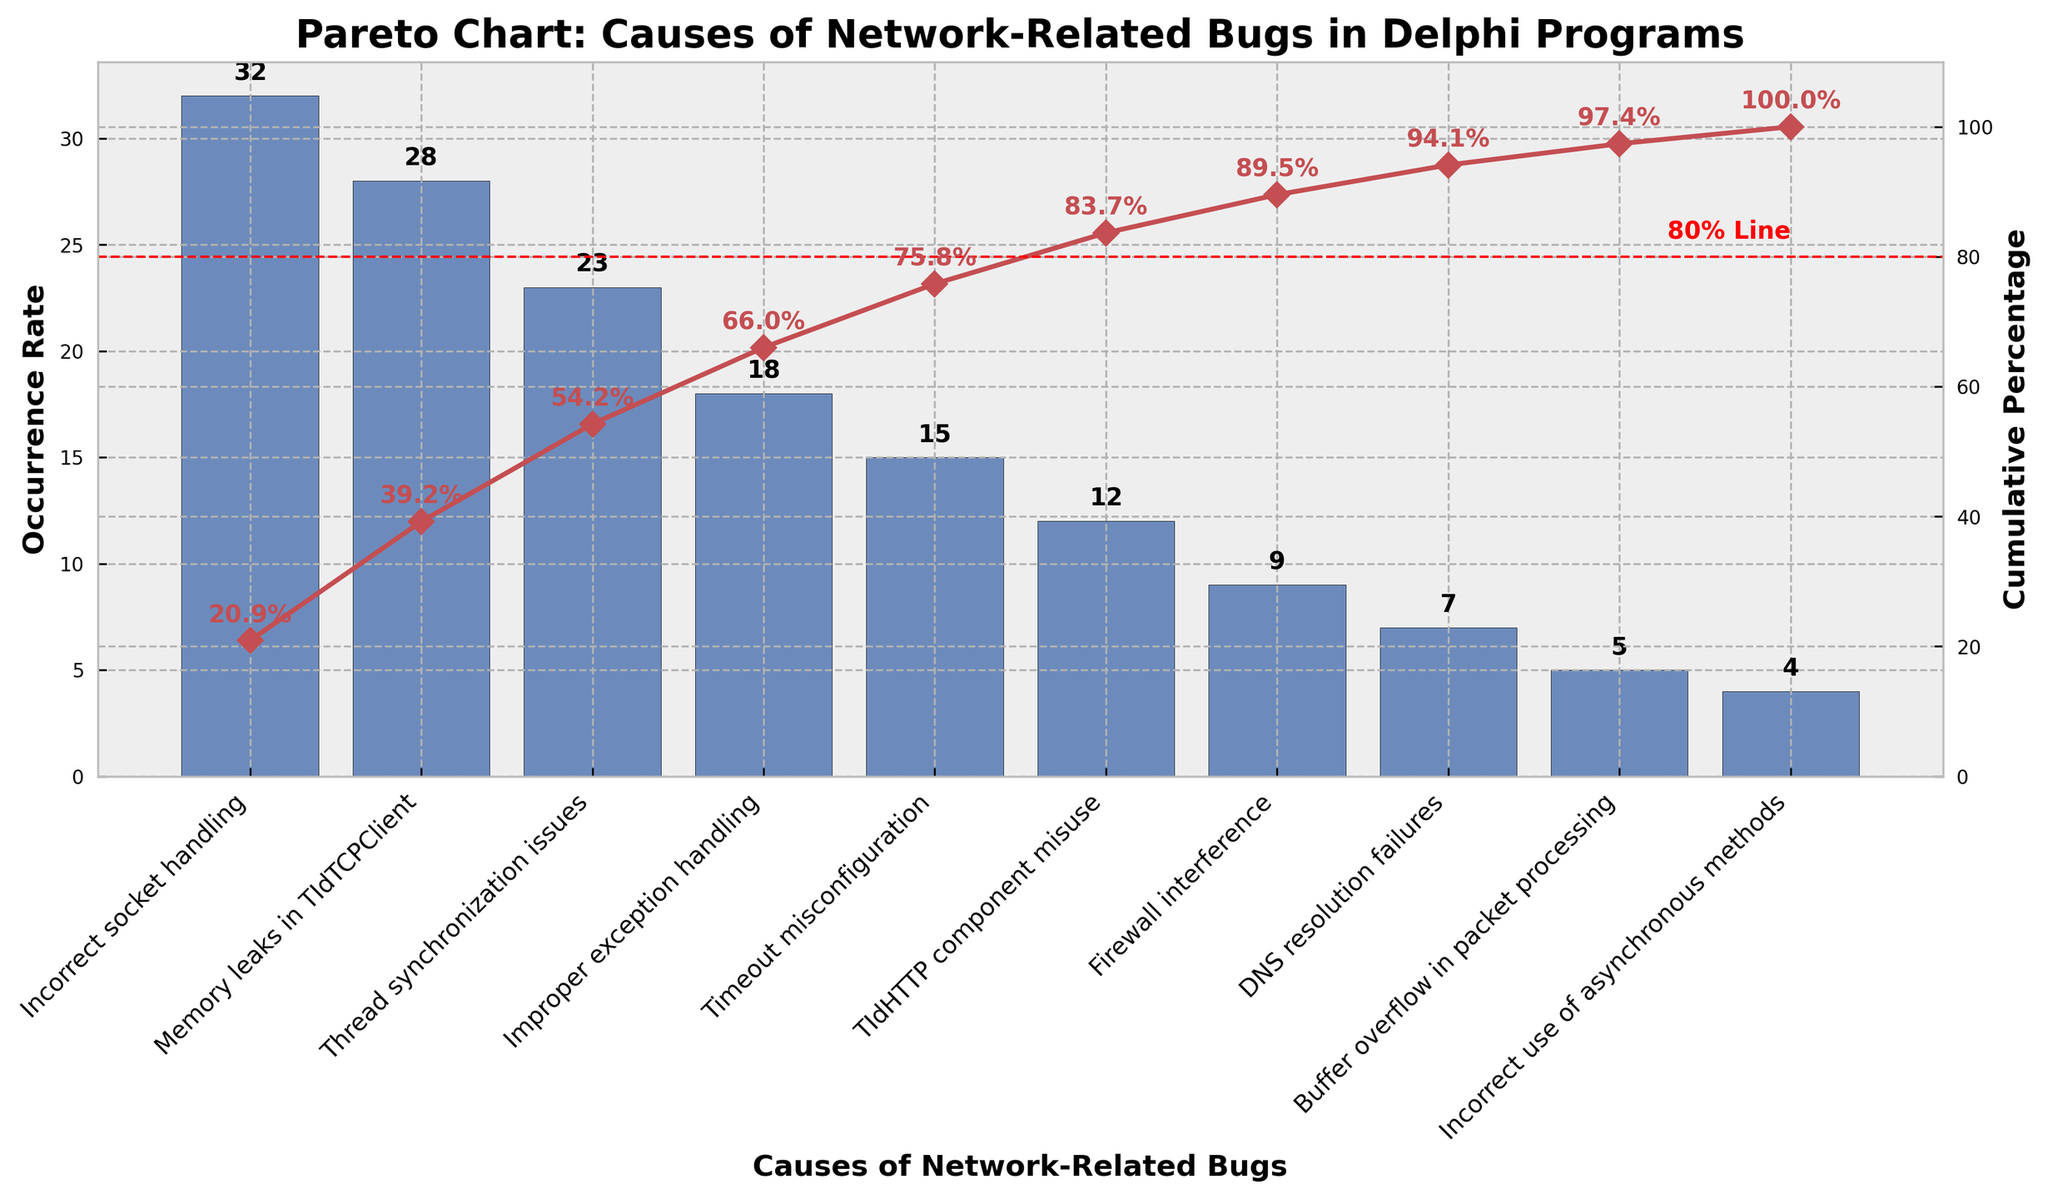What's the occurrence rate of "Improper exception handling"? Locate the bar labeled "Improper exception handling" on the x-axis and read the value on the y-axis corresponding to it.
Answer: 18 What is the combined occurrence rate for "Memory leaks in TIdTCPClient" and "Thread synchronization issues"? Identify the bars for "Memory leaks in TIdTCPClient" and "Thread synchronization issues", then sum their y-axis values: 28 + 23.
Answer: 51 Which cause has the highest occurrence rate? Find the bar with the highest value on the y-axis.
Answer: Incorrect socket handling What is the cumulative percentage after including "Timeout misconfiguration"? Locate the point on the cumulative percentage line that corresponds to "Timeout misconfiguration" and read its value on the secondary y-axis.
Answer: 78.3% How many causes contribute to reaching the 80% cumulative percentage line? Trace the cumulative percentage line from 0% to 80% and count how many causes it passes through.
Answer: 5 Which two causes have the lowest occurrence rates? Find the two shortest bars in the chart.
Answer: Incorrect use of asynchronous methods and Buffer overflow in packet processing Approximately what percentage of network-related bugs are caused by the top three causes? Find the cumulative percentage value at the third cause, which in this case is "Thread synchronization issues".
Answer: 83% What is the occurrence rate difference between "TIdHTTP component misuse" and "Firewall interference"? Find the y-axis values for "TIdHTTP component misuse" and "Firewall interference", then subtract the smaller value from the larger one: 12 - 9.
Answer: 3 How many causes have an occurrence rate of less than 10? Count the number of bars with y-axis values less than 10.
Answer: 4 What is the cumulative percentage for "DNS resolution failures"? Locate the point on the cumulative percentage line corresponding to "DNS resolution failures" and read the value on the secondary y-axis.
Answer: 97% 